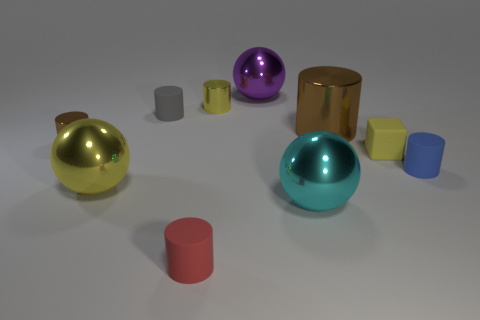Subtract 2 cylinders. How many cylinders are left? 4 Subtract all tiny yellow cylinders. How many cylinders are left? 5 Subtract all red cylinders. How many cylinders are left? 5 Subtract all brown cylinders. Subtract all cyan blocks. How many cylinders are left? 4 Subtract all cylinders. How many objects are left? 4 Subtract all big cyan rubber cylinders. Subtract all tiny rubber things. How many objects are left? 6 Add 5 purple shiny spheres. How many purple shiny spheres are left? 6 Add 5 tiny yellow objects. How many tiny yellow objects exist? 7 Subtract 1 cyan spheres. How many objects are left? 9 